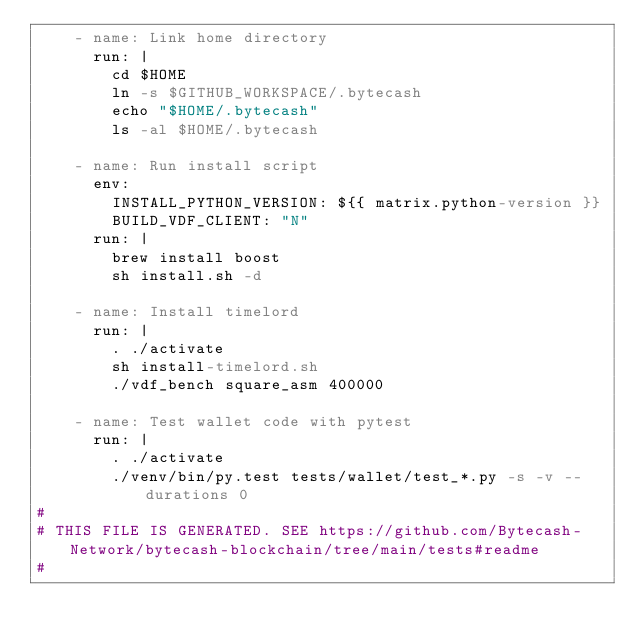<code> <loc_0><loc_0><loc_500><loc_500><_YAML_>    - name: Link home directory
      run: |
        cd $HOME
        ln -s $GITHUB_WORKSPACE/.bytecash
        echo "$HOME/.bytecash"
        ls -al $HOME/.bytecash

    - name: Run install script
      env:
        INSTALL_PYTHON_VERSION: ${{ matrix.python-version }}
        BUILD_VDF_CLIENT: "N"
      run: |
        brew install boost
        sh install.sh -d

    - name: Install timelord
      run: |
        . ./activate
        sh install-timelord.sh
        ./vdf_bench square_asm 400000

    - name: Test wallet code with pytest
      run: |
        . ./activate
        ./venv/bin/py.test tests/wallet/test_*.py -s -v --durations 0
#
# THIS FILE IS GENERATED. SEE https://github.com/Bytecash-Network/bytecash-blockchain/tree/main/tests#readme
#
</code> 